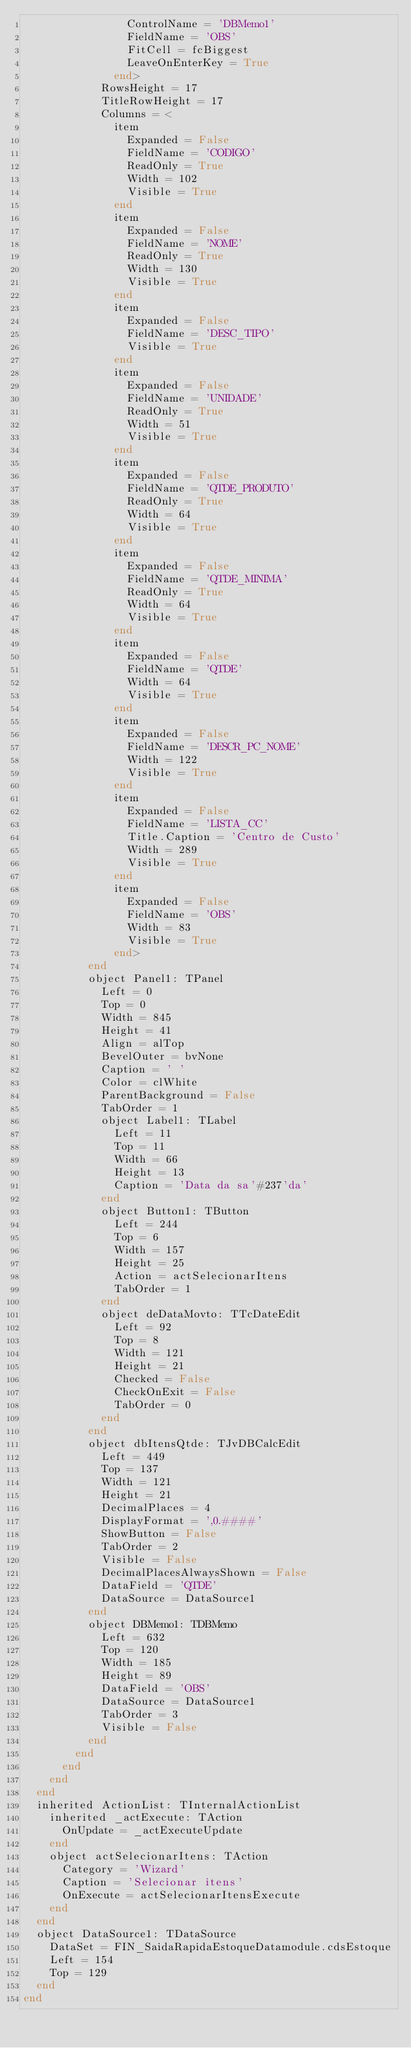Convert code to text. <code><loc_0><loc_0><loc_500><loc_500><_Pascal_>                ControlName = 'DBMemo1'
                FieldName = 'OBS'
                FitCell = fcBiggest
                LeaveOnEnterKey = True
              end>
            RowsHeight = 17
            TitleRowHeight = 17
            Columns = <
              item
                Expanded = False
                FieldName = 'CODIGO'
                ReadOnly = True
                Width = 102
                Visible = True
              end
              item
                Expanded = False
                FieldName = 'NOME'
                ReadOnly = True
                Width = 130
                Visible = True
              end
              item
                Expanded = False
                FieldName = 'DESC_TIPO'
                Visible = True
              end
              item
                Expanded = False
                FieldName = 'UNIDADE'
                ReadOnly = True
                Width = 51
                Visible = True
              end
              item
                Expanded = False
                FieldName = 'QTDE_PRODUTO'
                ReadOnly = True
                Width = 64
                Visible = True
              end
              item
                Expanded = False
                FieldName = 'QTDE_MINIMA'
                ReadOnly = True
                Width = 64
                Visible = True
              end
              item
                Expanded = False
                FieldName = 'QTDE'
                Width = 64
                Visible = True
              end
              item
                Expanded = False
                FieldName = 'DESCR_PC_NOME'
                Width = 122
                Visible = True
              end
              item
                Expanded = False
                FieldName = 'LISTA_CC'
                Title.Caption = 'Centro de Custo'
                Width = 289
                Visible = True
              end
              item
                Expanded = False
                FieldName = 'OBS'
                Width = 83
                Visible = True
              end>
          end
          object Panel1: TPanel
            Left = 0
            Top = 0
            Width = 845
            Height = 41
            Align = alTop
            BevelOuter = bvNone
            Caption = ' '
            Color = clWhite
            ParentBackground = False
            TabOrder = 1
            object Label1: TLabel
              Left = 11
              Top = 11
              Width = 66
              Height = 13
              Caption = 'Data da sa'#237'da'
            end
            object Button1: TButton
              Left = 244
              Top = 6
              Width = 157
              Height = 25
              Action = actSelecionarItens
              TabOrder = 1
            end
            object deDataMovto: TTcDateEdit
              Left = 92
              Top = 8
              Width = 121
              Height = 21
              Checked = False
              CheckOnExit = False
              TabOrder = 0
            end
          end
          object dbItensQtde: TJvDBCalcEdit
            Left = 449
            Top = 137
            Width = 121
            Height = 21
            DecimalPlaces = 4
            DisplayFormat = ',0.####'
            ShowButton = False
            TabOrder = 2
            Visible = False
            DecimalPlacesAlwaysShown = False
            DataField = 'QTDE'
            DataSource = DataSource1
          end
          object DBMemo1: TDBMemo
            Left = 632
            Top = 120
            Width = 185
            Height = 89
            DataField = 'OBS'
            DataSource = DataSource1
            TabOrder = 3
            Visible = False
          end
        end
      end
    end
  end
  inherited ActionList: TInternalActionList
    inherited _actExecute: TAction
      OnUpdate = _actExecuteUpdate
    end
    object actSelecionarItens: TAction
      Category = 'Wizard'
      Caption = 'Selecionar itens'
      OnExecute = actSelecionarItensExecute
    end
  end
  object DataSource1: TDataSource
    DataSet = FIN_SaidaRapidaEstoqueDatamodule.cdsEstoque
    Left = 154
    Top = 129
  end
end
</code> 